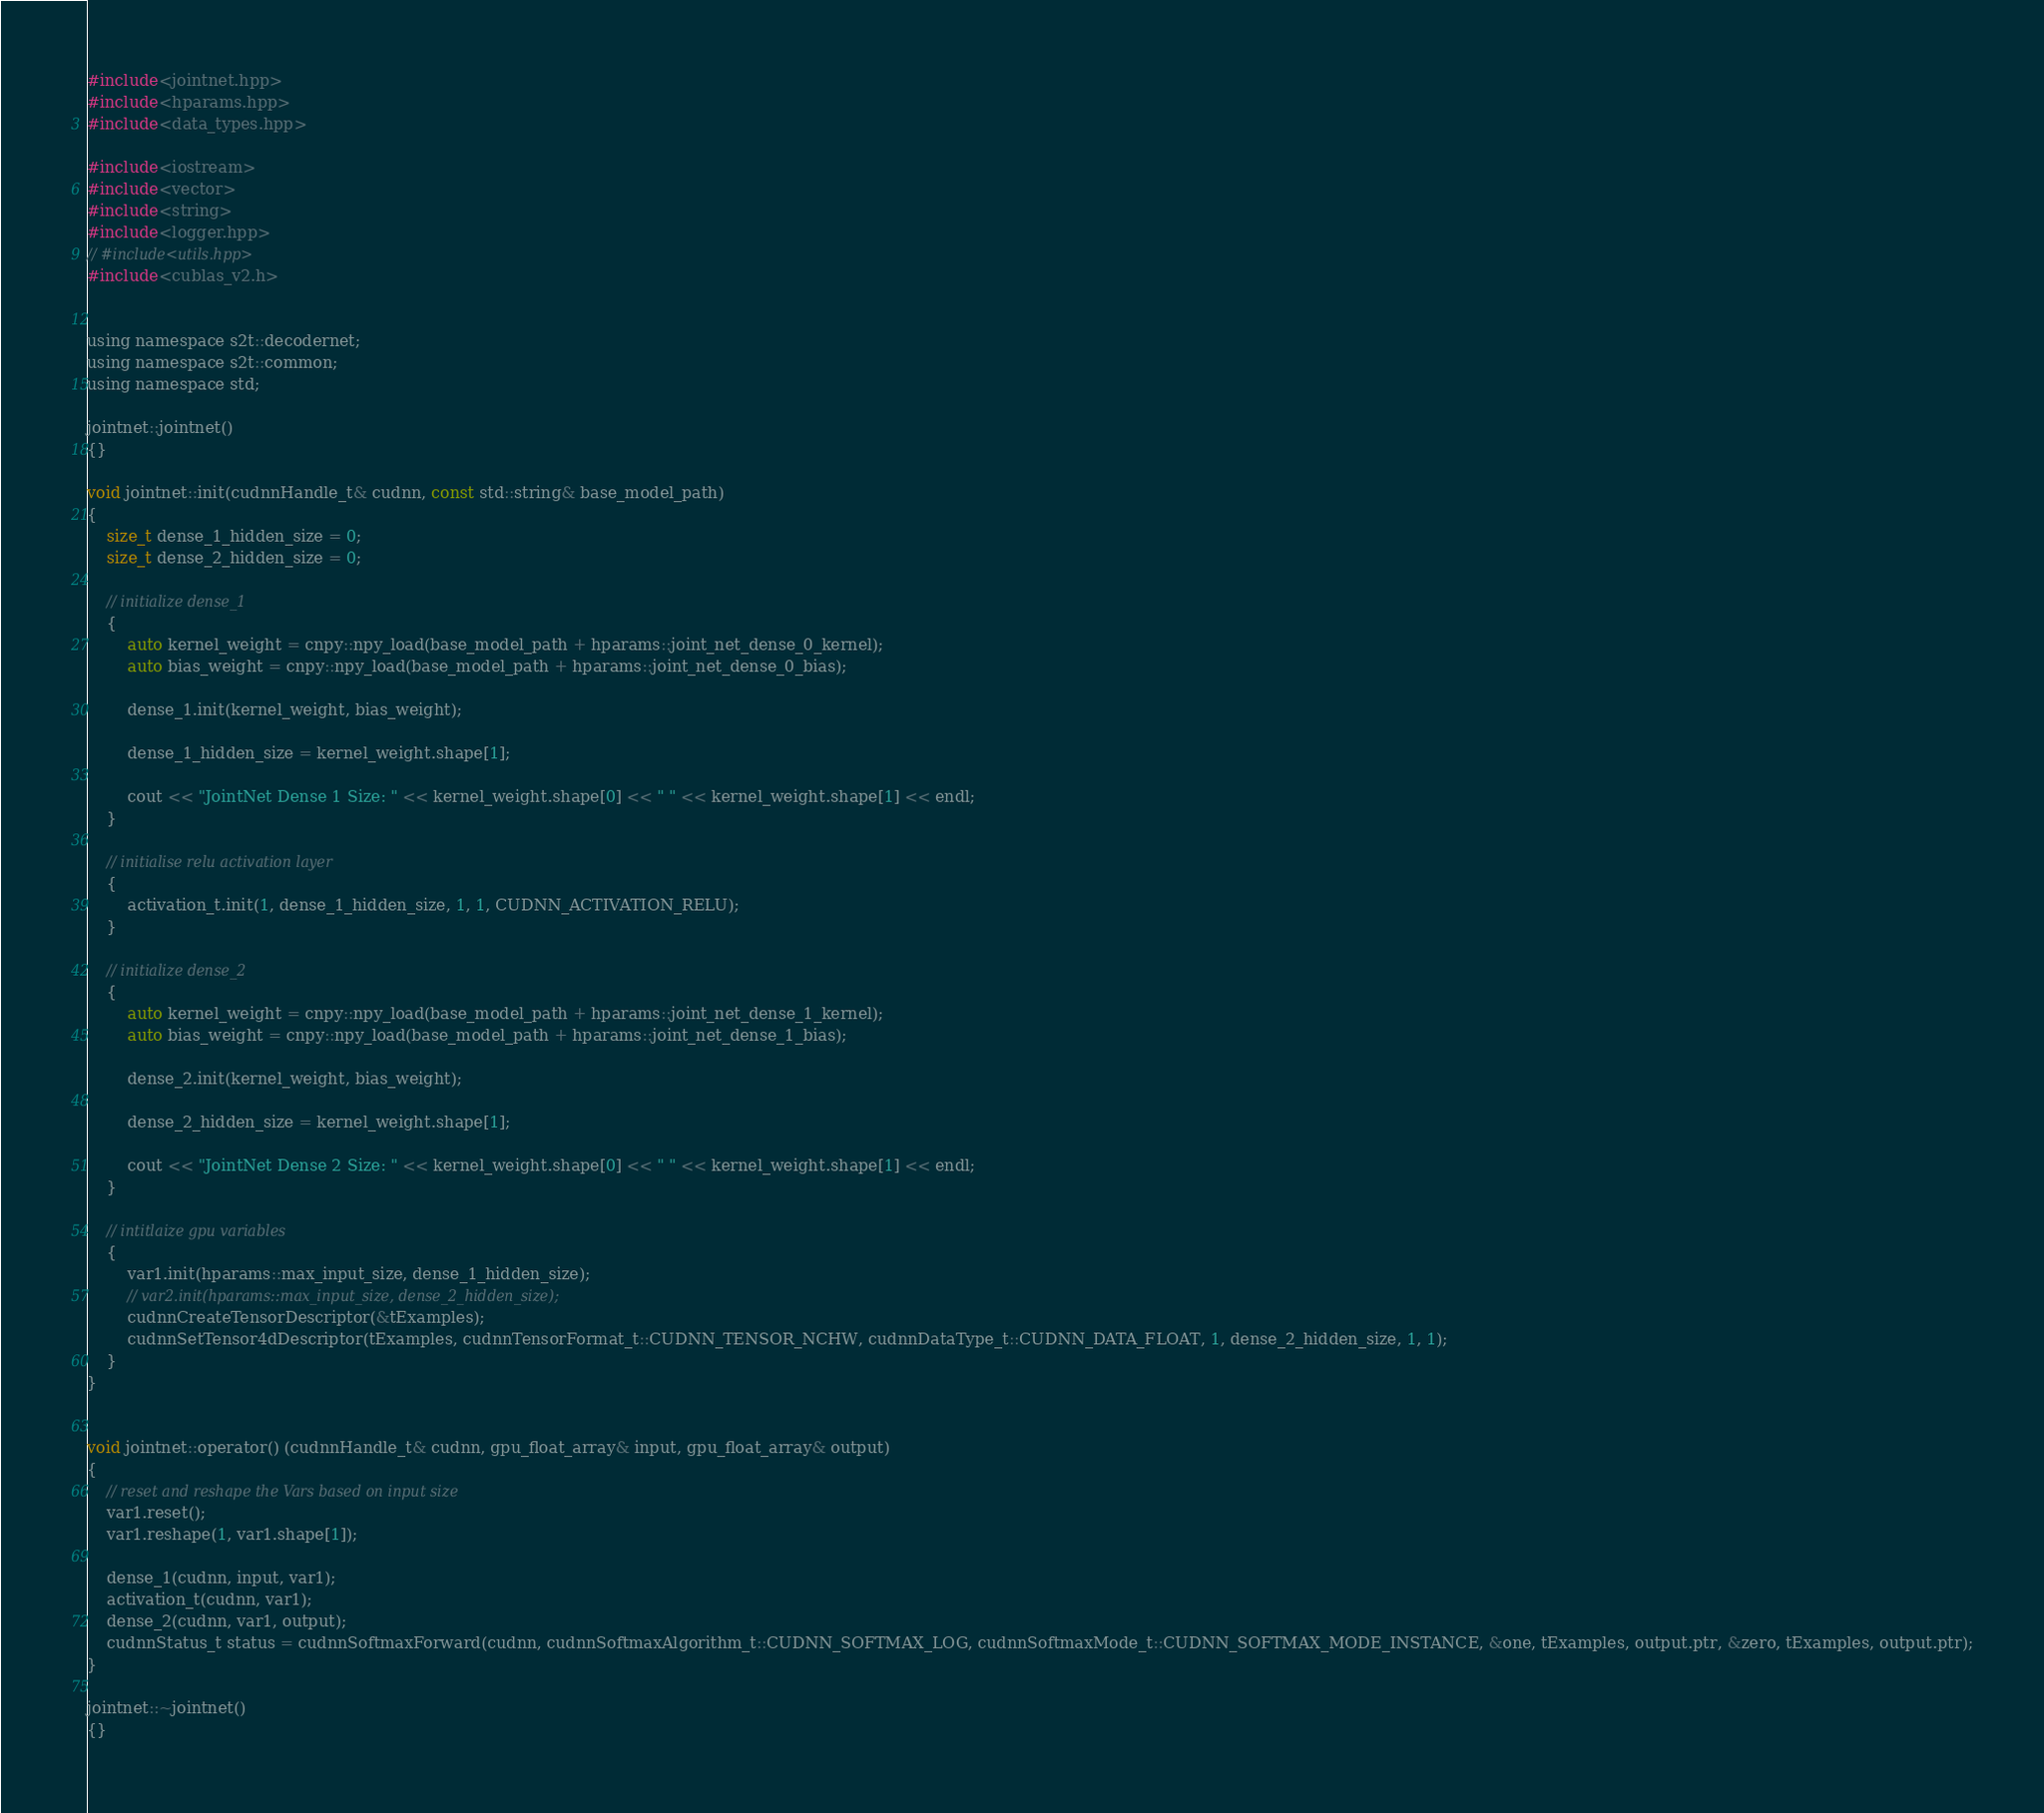Convert code to text. <code><loc_0><loc_0><loc_500><loc_500><_Cuda_>#include<jointnet.hpp>
#include<hparams.hpp>
#include<data_types.hpp>

#include<iostream>
#include<vector>
#include<string>
#include<logger.hpp>
// #include<utils.hpp>
#include<cublas_v2.h>


using namespace s2t::decodernet;
using namespace s2t::common;
using namespace std;

jointnet::jointnet()
{}

void jointnet::init(cudnnHandle_t& cudnn, const std::string& base_model_path)
{
	size_t dense_1_hidden_size = 0;
	size_t dense_2_hidden_size = 0;

	// initialize dense_1
	{
		auto kernel_weight = cnpy::npy_load(base_model_path + hparams::joint_net_dense_0_kernel); 
		auto bias_weight = cnpy::npy_load(base_model_path + hparams::joint_net_dense_0_bias);

        dense_1.init(kernel_weight, bias_weight);
        
		dense_1_hidden_size = kernel_weight.shape[1]; 
		
		cout << "JointNet Dense 1 Size: " << kernel_weight.shape[0] << " " << kernel_weight.shape[1] << endl;
	}
	
	// initialise relu activation layer
	{
		activation_t.init(1, dense_1_hidden_size, 1, 1, CUDNN_ACTIVATION_RELU);
	}
    
	// initialize dense_2
	{
		auto kernel_weight = cnpy::npy_load(base_model_path + hparams::joint_net_dense_1_kernel); 
		auto bias_weight = cnpy::npy_load(base_model_path + hparams::joint_net_dense_1_bias);

		dense_2.init(kernel_weight, bias_weight);

		dense_2_hidden_size = kernel_weight.shape[1]; 

		cout << "JointNet Dense 2 Size: " << kernel_weight.shape[0] << " " << kernel_weight.shape[1] << endl;
	}

	// intitlaize gpu variables
	{
		var1.init(hparams::max_input_size, dense_1_hidden_size);
		// var2.init(hparams::max_input_size, dense_2_hidden_size);
		cudnnCreateTensorDescriptor(&tExamples);
		cudnnSetTensor4dDescriptor(tExamples, cudnnTensorFormat_t::CUDNN_TENSOR_NCHW, cudnnDataType_t::CUDNN_DATA_FLOAT, 1, dense_2_hidden_size, 1, 1);
	}	
}


void jointnet::operator() (cudnnHandle_t& cudnn, gpu_float_array& input, gpu_float_array& output)
{
    // reset and reshape the Vars based on input size
	var1.reset();
	var1.reshape(1, var1.shape[1]);

	dense_1(cudnn, input, var1);
	activation_t(cudnn, var1);
	dense_2(cudnn, var1, output);
	cudnnStatus_t status = cudnnSoftmaxForward(cudnn, cudnnSoftmaxAlgorithm_t::CUDNN_SOFTMAX_LOG, cudnnSoftmaxMode_t::CUDNN_SOFTMAX_MODE_INSTANCE, &one, tExamples, output.ptr, &zero, tExamples, output.ptr);
}

jointnet::~jointnet()
{}</code> 